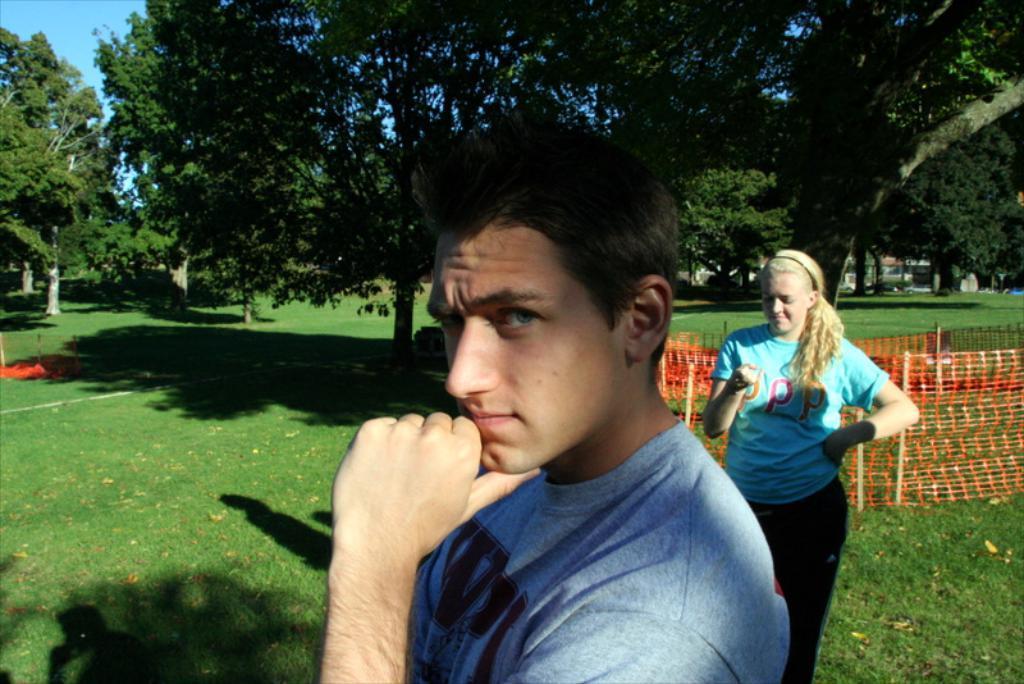Please provide a concise description of this image. In this image we can see a man and a woman standing on the grass field. On the right side of the image we can see a fence, some wooden poles, vehicles parked on the ground and a building. At the top of the image we can see a group of trees and the sky. 